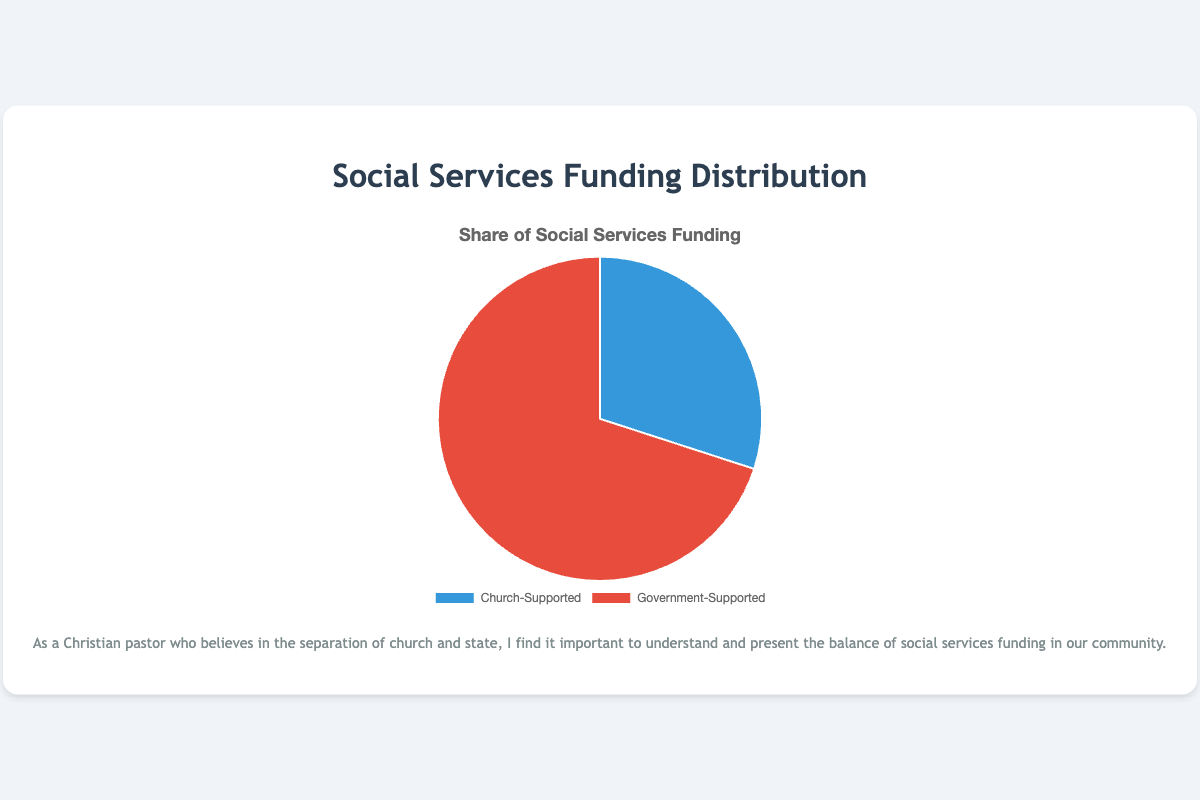What is the share of social services funding provided by the church? The pie chart shows two segments with Church-Supported social services represented in blue. The data point for Church-Supported is 30%.
Answer: 30% Which type of social services funding is greater in the community? The figure shows two types of funding: Church-Supported and Government-Supported. The Government-Supported segment is larger, showing 70% compared to Church-Supported with 30%.
Answer: Government-Supported What is the difference in percentage between government-supported and church-supported social services funding? Government-Supported funding is 70%, and Church-Supported funding is 30%. The difference is computed as 70% - 30%.
Answer: 40% If we combine the percentages of services provided by St. Mary's Community Outreach and New Hope Fellowship Assistance, what will the total be? Both St. Mary's Community Outreach and New Hope Fellowship Assistance are Church-Supported with 15% each. The total is 15% + 15%.
Answer: 30% Which organization provides more types of services for Church-supported social services? Both St. Mary's Community Outreach and New Hope Fellowship Assistance provide three types of services each.
Answer: They provide equal types Is there any visual indication which type of social services funding is less dominant in the community? The pie chart shows that the Church-Supported segment is visually smaller than the Government-Supported segment.
Answer: Church-Supported Based on visual inspection, which color represents government-supported social services in the pie chart? The government-supported segment is shown in red as per the labels in the data section.
Answer: Red Considering both government-supported segments, what would be the total funding share if one of these segments was twice its current value? If one 40% government-supported segment doubles to 80%, combined with the other 30%, the total would exceed 100%, indicating unrealistic funding percentages surpassing the sum of parts.
Answer: Unrealistic (exceeds 100%) What percentage of social services funding is provided by County Health and Human Services and City Welfare Department together? City Welfare Department provides 40% and County Health and Human Services provides 30%. Combined, this sums to 40% + 30%.
Answer: 70% Which segment in the pie chart would be  more aligned with the concept of separation of church and state as per your belief? The Government-Supported services would be more aligned with the concept of separation of church and state, as they are not church-affiliated.
Answer: Government-Supported 